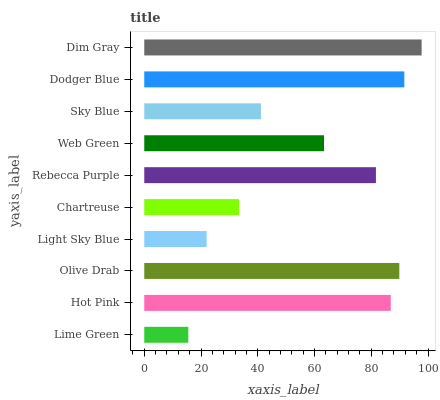Is Lime Green the minimum?
Answer yes or no. Yes. Is Dim Gray the maximum?
Answer yes or no. Yes. Is Hot Pink the minimum?
Answer yes or no. No. Is Hot Pink the maximum?
Answer yes or no. No. Is Hot Pink greater than Lime Green?
Answer yes or no. Yes. Is Lime Green less than Hot Pink?
Answer yes or no. Yes. Is Lime Green greater than Hot Pink?
Answer yes or no. No. Is Hot Pink less than Lime Green?
Answer yes or no. No. Is Rebecca Purple the high median?
Answer yes or no. Yes. Is Web Green the low median?
Answer yes or no. Yes. Is Olive Drab the high median?
Answer yes or no. No. Is Olive Drab the low median?
Answer yes or no. No. 